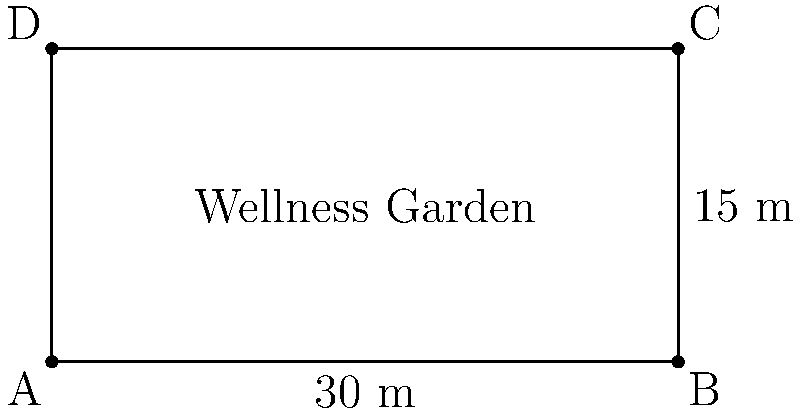As part of a new therapeutic intervention study, you're designing a rectangular wellness garden for patients. The garden measures 30 meters in length and 15 meters in width. What is the perimeter of this wellness garden? To find the perimeter of the rectangular wellness garden, we need to follow these steps:

1. Recall the formula for the perimeter of a rectangle:
   $$ P = 2l + 2w $$
   where $P$ is the perimeter, $l$ is the length, and $w$ is the width.

2. Identify the given dimensions:
   Length $(l) = 30$ meters
   Width $(w) = 15$ meters

3. Substitute these values into the formula:
   $$ P = 2(30) + 2(15) $$

4. Simplify:
   $$ P = 60 + 30 $$

5. Calculate the final result:
   $$ P = 90 $$

Therefore, the perimeter of the wellness garden is 90 meters.
Answer: 90 meters 